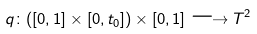Convert formula to latex. <formula><loc_0><loc_0><loc_500><loc_500>q \colon ( [ 0 , 1 ] \times [ 0 , t _ { 0 } ] ) \times [ 0 , 1 ] \longrightarrow T ^ { 2 }</formula> 